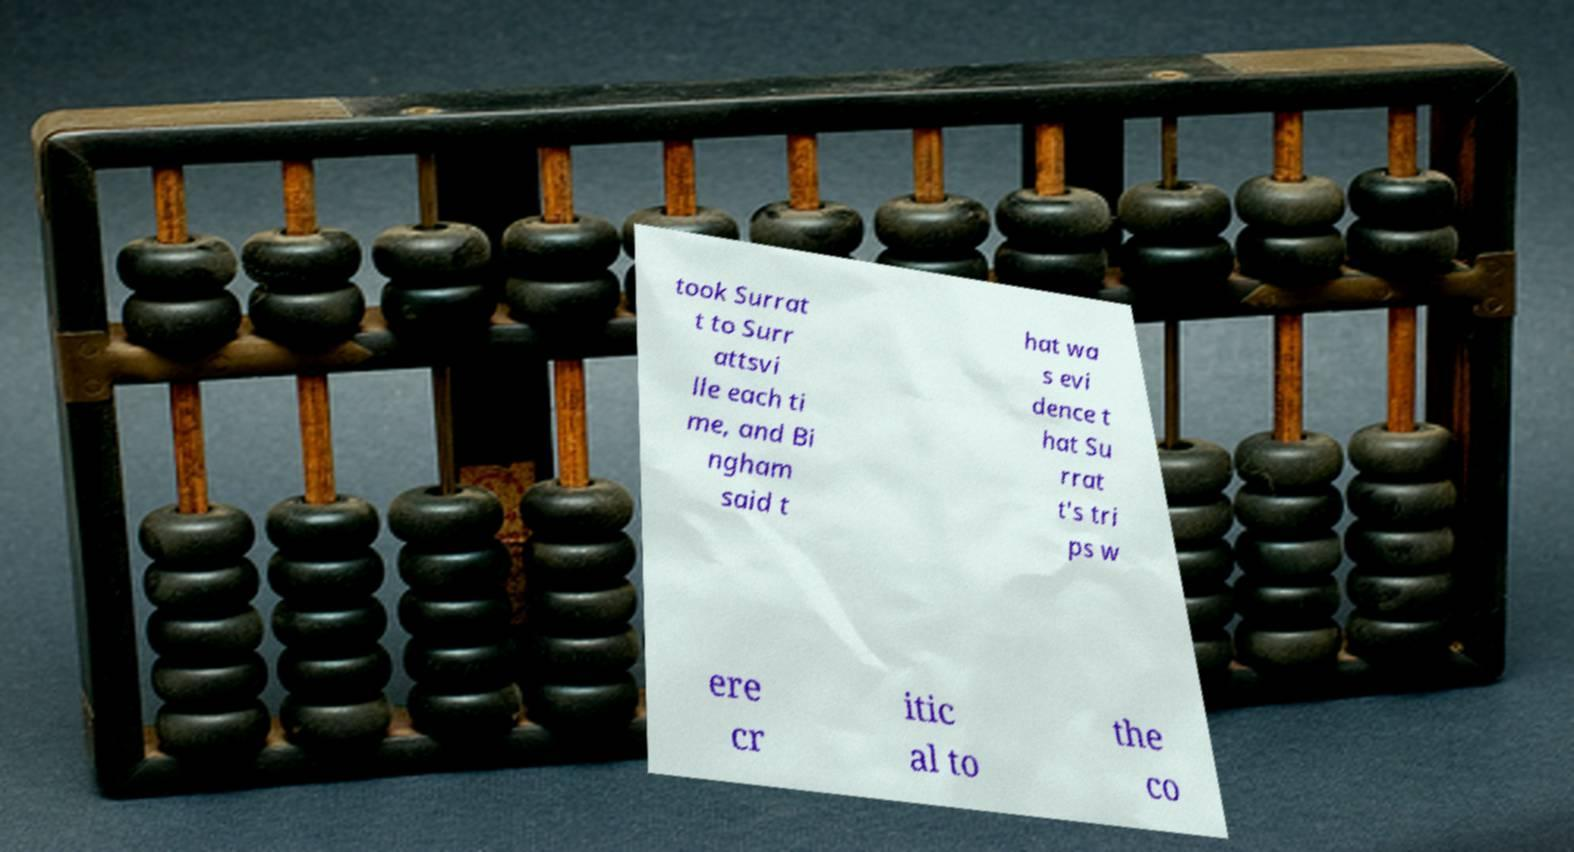I need the written content from this picture converted into text. Can you do that? took Surrat t to Surr attsvi lle each ti me, and Bi ngham said t hat wa s evi dence t hat Su rrat t's tri ps w ere cr itic al to the co 